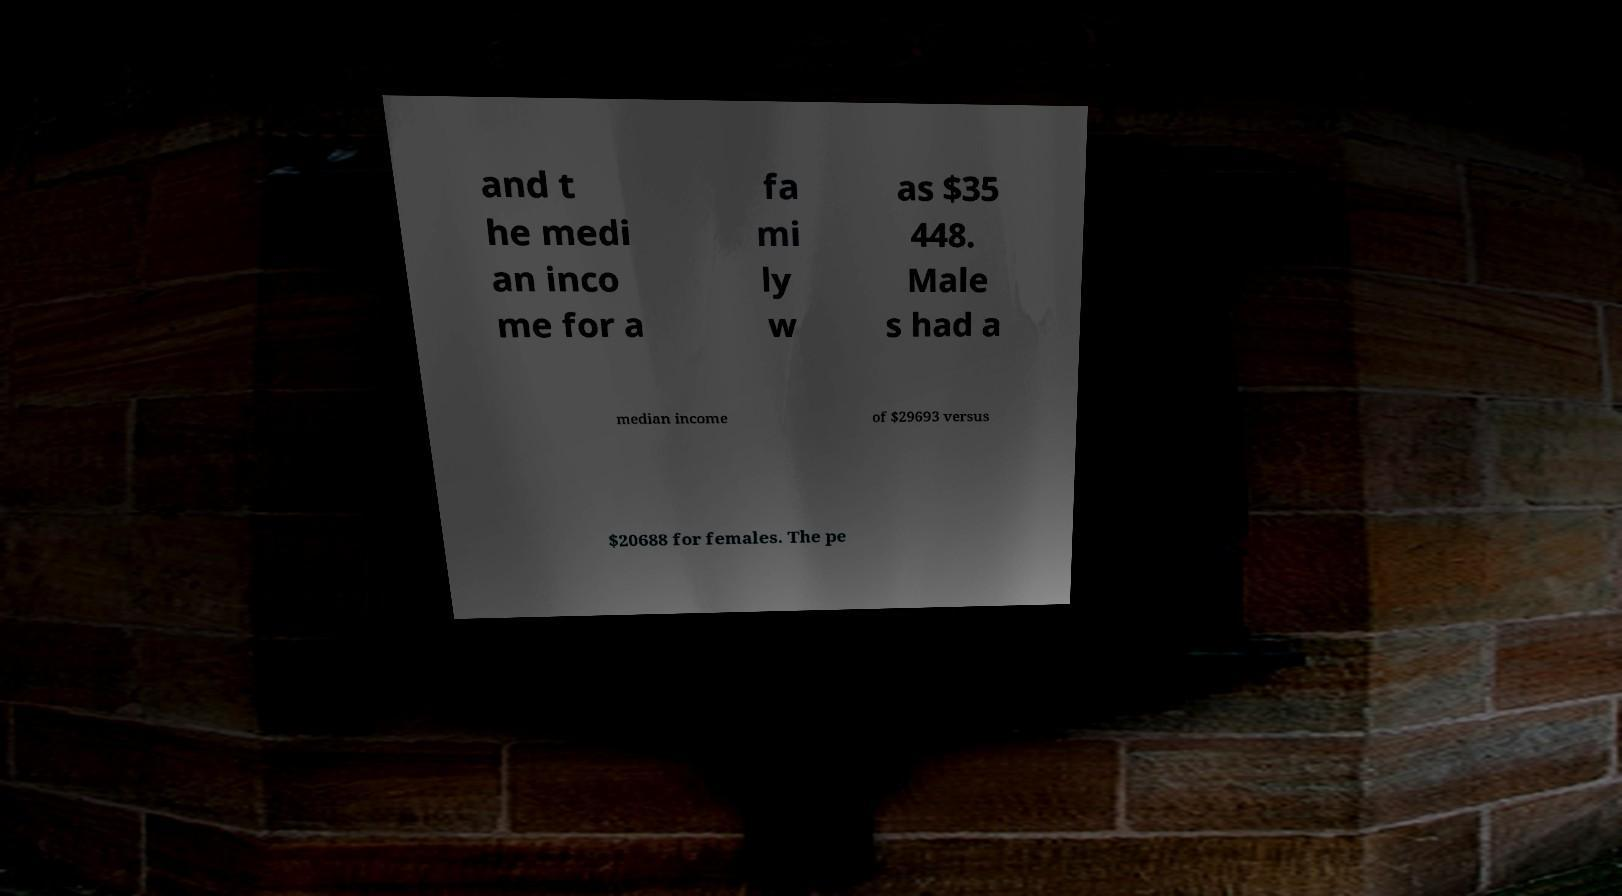What messages or text are displayed in this image? I need them in a readable, typed format. and t he medi an inco me for a fa mi ly w as $35 448. Male s had a median income of $29693 versus $20688 for females. The pe 